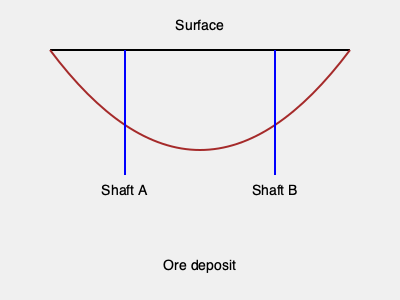Given the 2D cross-sectional view of a mine with two potential shaft locations (A and B), which shaft location would be most cost-effective for extracting the ore deposit, assuming uniform extraction costs per unit depth and ignoring horizontal transportation costs? To determine the most cost-effective shaft location, we need to compare the depths of shafts A and B:

1. The cost of shaft excavation is directly proportional to its depth.
2. Shaft A is located at x = 125 units, while Shaft B is at x = 275 units on the horizontal axis.
3. The ore deposit curve can be approximated by a quadratic function: $y = ax^2 + bx + c$
4. Given the symmetry of the curve, we can assume the vertex is at x = 200 units.
5. The depths of the shafts are:
   - Depth A = 175 - 50 = 125 units
   - Depth B = 175 - 50 = 125 units
6. Since both shafts have equal depth, the excavation costs would be the same.
7. However, Shaft A is closer to the left edge of the deposit, while Shaft B is closer to the right edge.
8. Choosing Shaft A would allow for easier expansion to the left if needed, potentially accessing more of the deposit in the future.

Therefore, although both shafts have equal depth and initial cost, Shaft A provides more flexibility for future expansion and is the more cost-effective choice in the long term.
Answer: Shaft A 